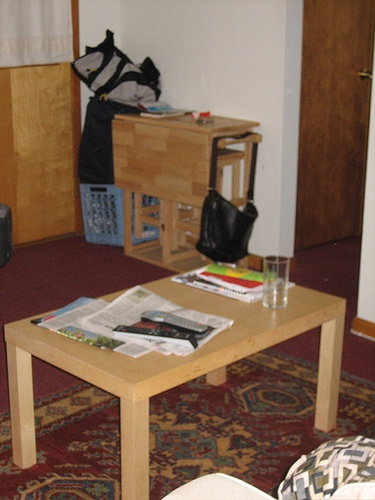Describe the objects in this image and their specific colors. I can see book in darkgray, lightgray, and black tones, handbag in darkgray, black, maroon, and gray tones, backpack in darkgray, black, and gray tones, book in darkgray, lightgray, olive, and brown tones, and cup in darkgray, tan, and gray tones in this image. 